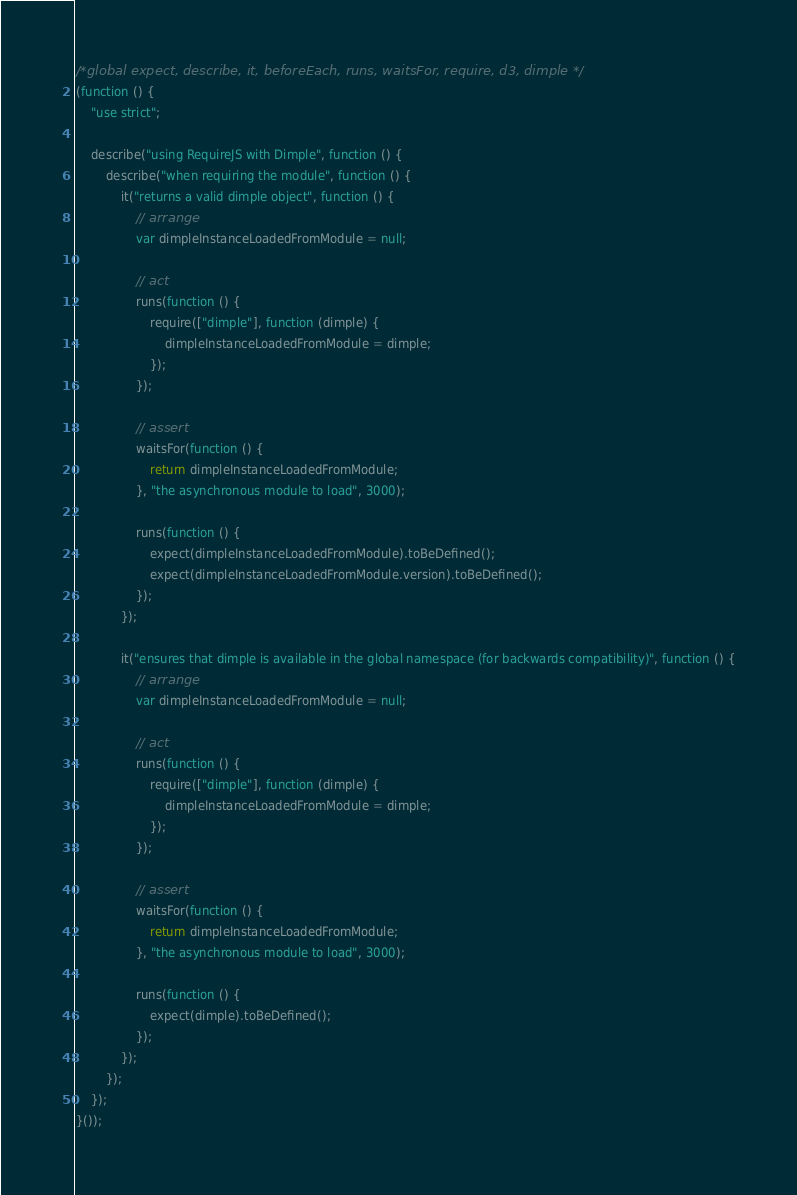<code> <loc_0><loc_0><loc_500><loc_500><_JavaScript_>/*global expect, describe, it, beforeEach, runs, waitsFor, require, d3, dimple */
(function () {
    "use strict";

    describe("using RequireJS with Dimple", function () {
        describe("when requiring the module", function () {
            it("returns a valid dimple object", function () {
                // arrange
                var dimpleInstanceLoadedFromModule = null;

                // act
                runs(function () {
                    require(["dimple"], function (dimple) {
                        dimpleInstanceLoadedFromModule = dimple;
                    });
                });

                // assert
                waitsFor(function () {
                    return dimpleInstanceLoadedFromModule;
                }, "the asynchronous module to load", 3000);

                runs(function () {
                    expect(dimpleInstanceLoadedFromModule).toBeDefined();
                    expect(dimpleInstanceLoadedFromModule.version).toBeDefined();
                });
            });

            it("ensures that dimple is available in the global namespace (for backwards compatibility)", function () {
                // arrange
                var dimpleInstanceLoadedFromModule = null;

                // act
                runs(function () {
                    require(["dimple"], function (dimple) {
                        dimpleInstanceLoadedFromModule = dimple;
                    });
                });

                // assert
                waitsFor(function () {
                    return dimpleInstanceLoadedFromModule;
                }, "the asynchronous module to load", 3000);

                runs(function () {
                    expect(dimple).toBeDefined();
                });
            });
        });
    });
}());</code> 